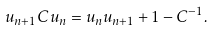Convert formula to latex. <formula><loc_0><loc_0><loc_500><loc_500>u _ { n + 1 } C u _ { n } = u _ { n } u _ { n + 1 } + 1 - C ^ { - 1 } .</formula> 